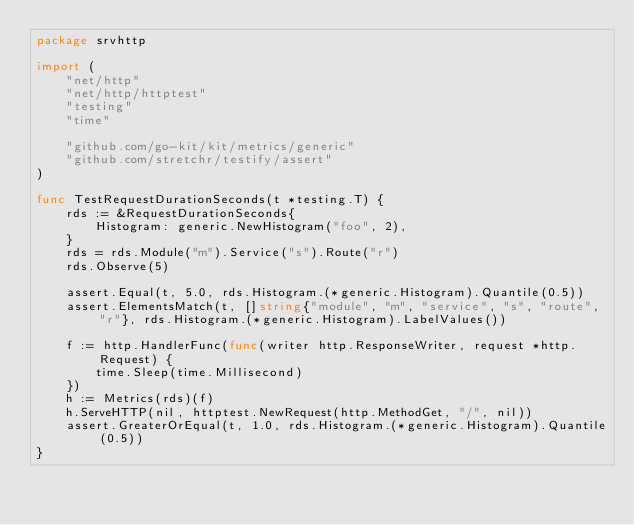<code> <loc_0><loc_0><loc_500><loc_500><_Go_>package srvhttp

import (
	"net/http"
	"net/http/httptest"
	"testing"
	"time"

	"github.com/go-kit/kit/metrics/generic"
	"github.com/stretchr/testify/assert"
)

func TestRequestDurationSeconds(t *testing.T) {
	rds := &RequestDurationSeconds{
		Histogram: generic.NewHistogram("foo", 2),
	}
	rds = rds.Module("m").Service("s").Route("r")
	rds.Observe(5)

	assert.Equal(t, 5.0, rds.Histogram.(*generic.Histogram).Quantile(0.5))
	assert.ElementsMatch(t, []string{"module", "m", "service", "s", "route", "r"}, rds.Histogram.(*generic.Histogram).LabelValues())

	f := http.HandlerFunc(func(writer http.ResponseWriter, request *http.Request) {
		time.Sleep(time.Millisecond)
	})
	h := Metrics(rds)(f)
	h.ServeHTTP(nil, httptest.NewRequest(http.MethodGet, "/", nil))
	assert.GreaterOrEqual(t, 1.0, rds.Histogram.(*generic.Histogram).Quantile(0.5))
}
</code> 